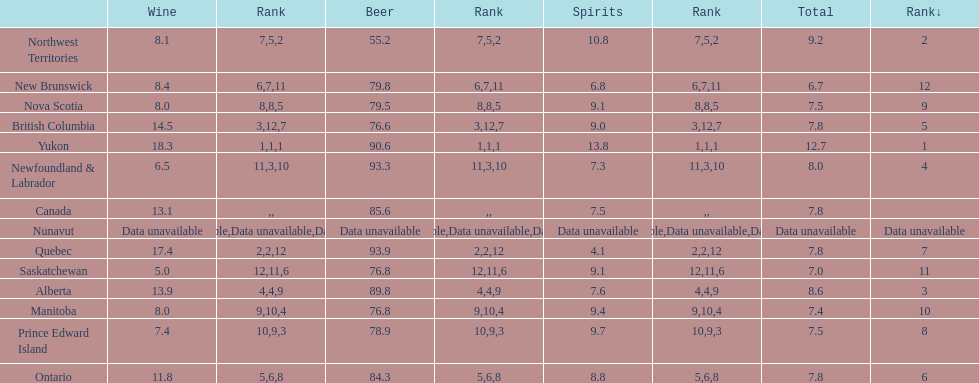Tell me province that drank more than 15 liters of wine. Yukon, Quebec. 